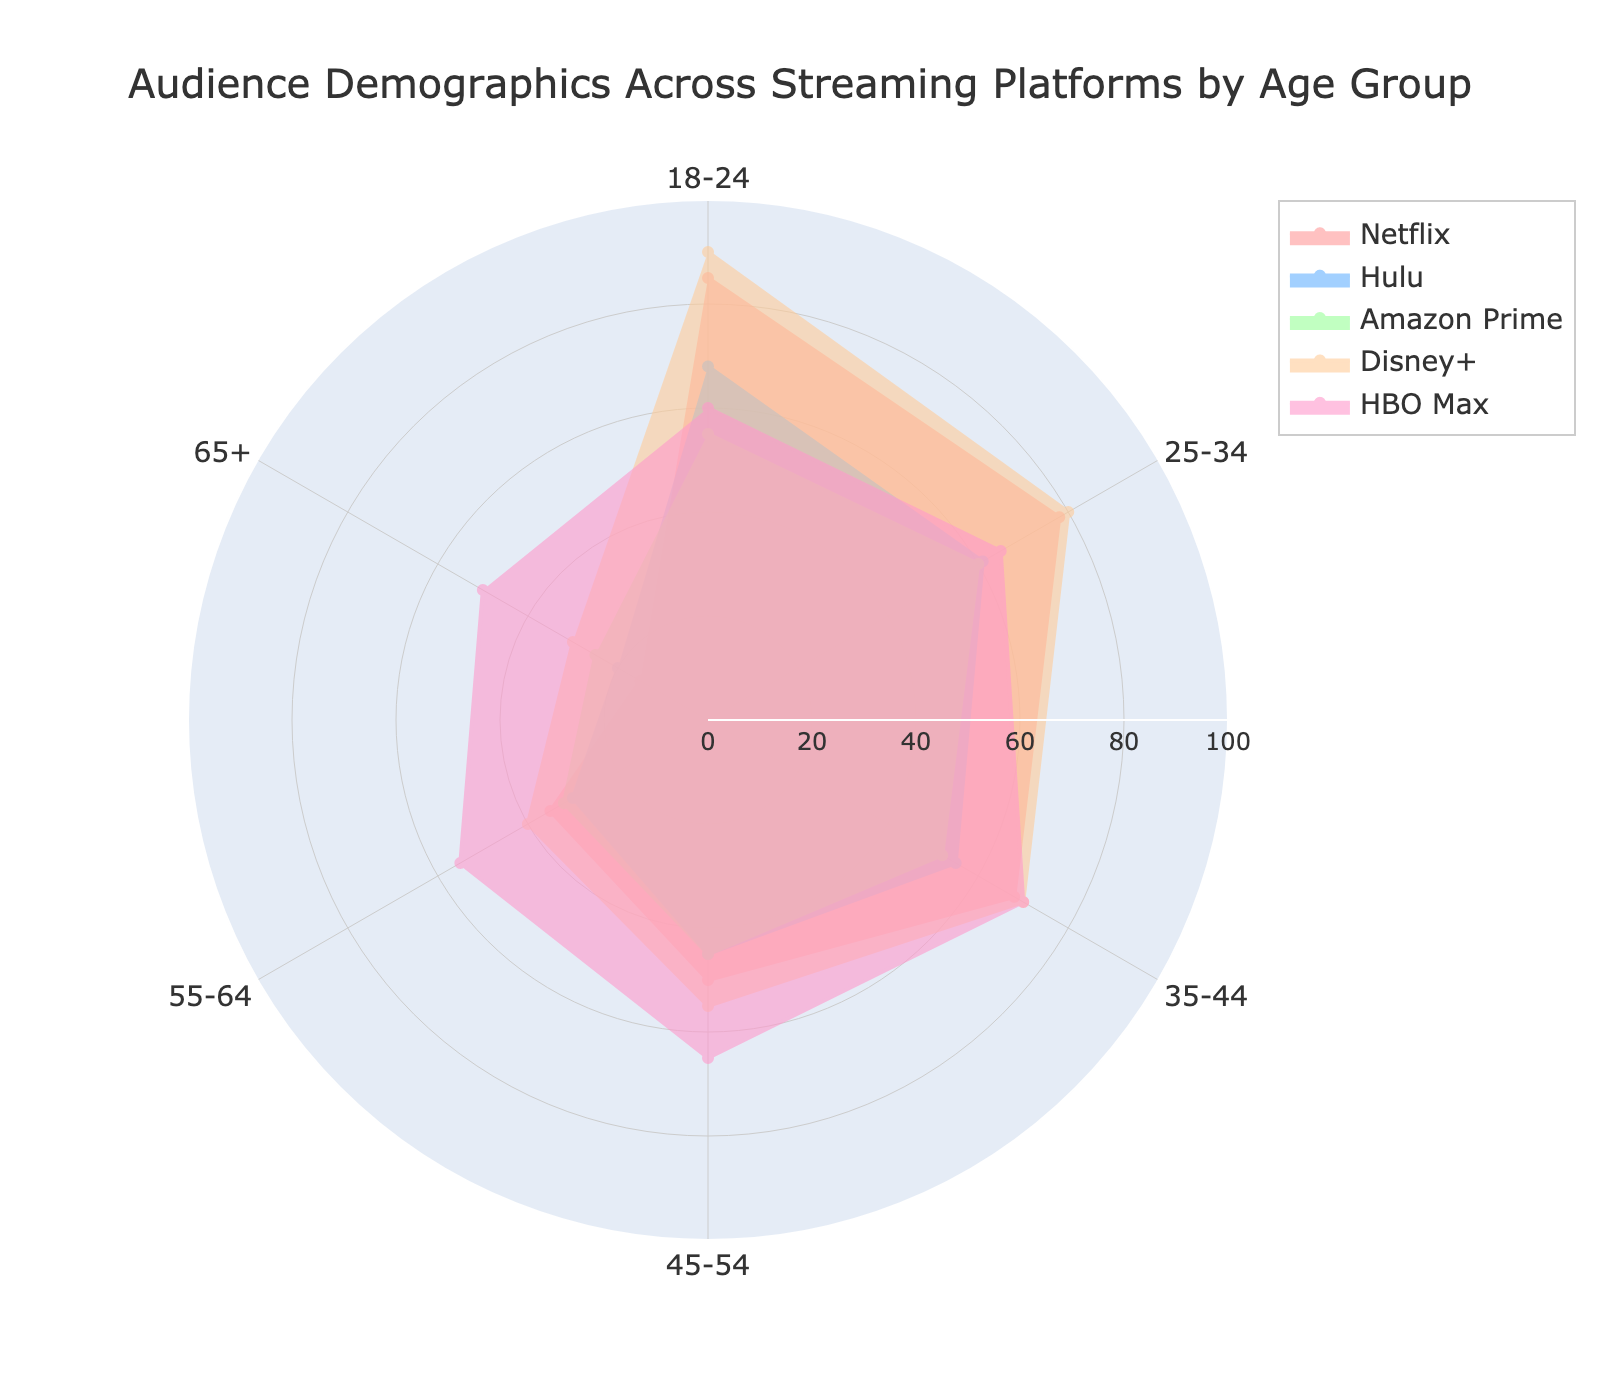What is the age group with the highest audience percentage for Netflix? The radar chart shows various age groups and their corresponding audience percentages across different streaming platforms. For Netflix, the age group 18-24 has the highest percentage at 85.
Answer: 18-24 Which age group shows the least interest in HBO Max? The radar chart indicates the audience percentages across age groups. The age group 18-24 has the lowest percentage for HBO Max at 60.
Answer: 18-24 What is the percentage difference between the 18-24 and 65+ age groups for Disney+? Disney+ has 90% for the 18-24 age group and 30% for the 65+ age group. The difference is 90 - 30 = 60.
Answer: 60 Which platform has the most balanced audience distribution across all age groups? Upon examining the radar chart, Disney+ has the most balanced distribution, as its audience percentages across age groups vary less dramatically.
Answer: Disney+ Compare the audience percentage between Hulu and Amazon Prime for the 25-34 age group. Which is higher? For the 25-34 age group, Hulu has an audience percentage of 61, while Amazon Prime has 60. Therefore, Hulu has a higher audience percentage.
Answer: Hulu Which age group has the lowest audience percentage for all platforms combined? By summing the percentages for each age group across all platforms: 18-24: 358, 25-34: 344, 35-44: 315, 45-54: 260, 55-64: 192, 65+: 140. The 65+ age group has the lowest total.
Answer: 65+ What's the average audience percentage for the age group 35-44 across all platforms? The values for 35-44 are 68, 55, 52, 70, and 70. The average can be calculated as (68 + 55 + 52 + 70 + 70) / 5 = 63.
Answer: 63 Identify the platform with the highest peak in audience percentage for any age group. The highest peak in the radar chart is Disney+ at 90% for the 18-24 age group.
Answer: Disney+ What is the difference in audience percentage for Netflix between the youngest (18-24) and oldest (65+) age groups? For Netflix, the 18-24 age group has 85%, and the 65+ group has 15%. The difference is 85 - 15 = 70.
Answer: 70 For the 55-64 age group, which streaming platform has the highest audience percentage? The radar chart shows that HBO Max has the highest percentage at 55 for the 55-64 age group.
Answer: HBO Max 